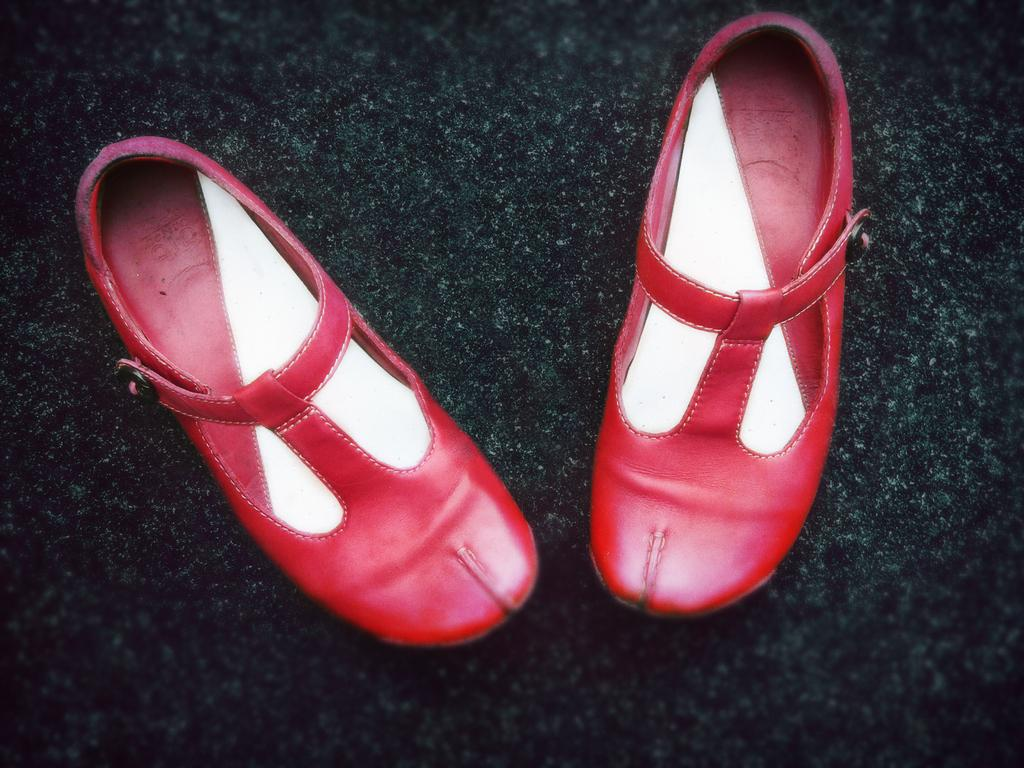What type of object is present in the image? There is footwear in the image. Where is the footwear located? The footwear is on a surface. What type of pipe can be seen connected to the footwear in the image? There is no pipe connected to the footwear in the image. What sound does the bell make when it is attached to the footwear in the image? There is no bell attached to the footwear in the image. 